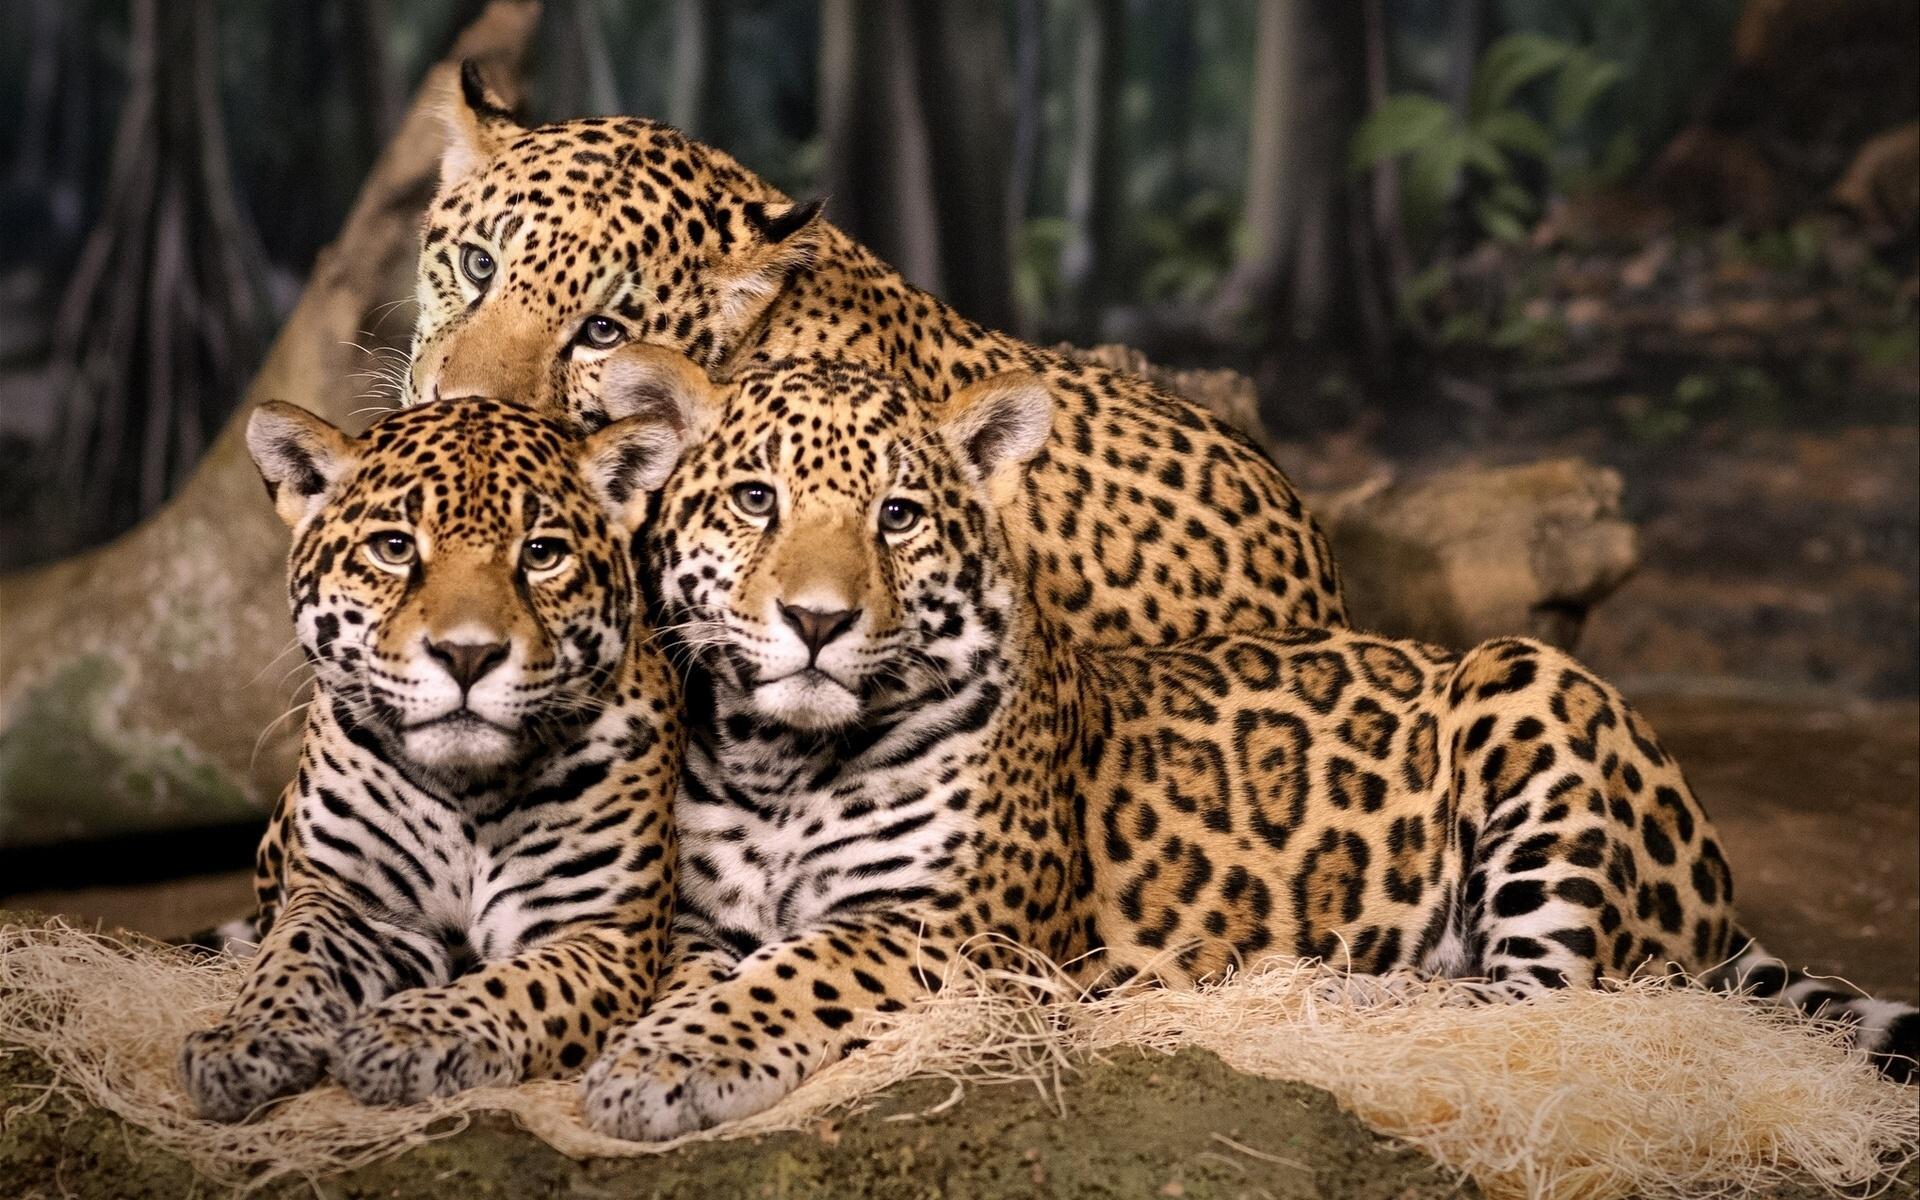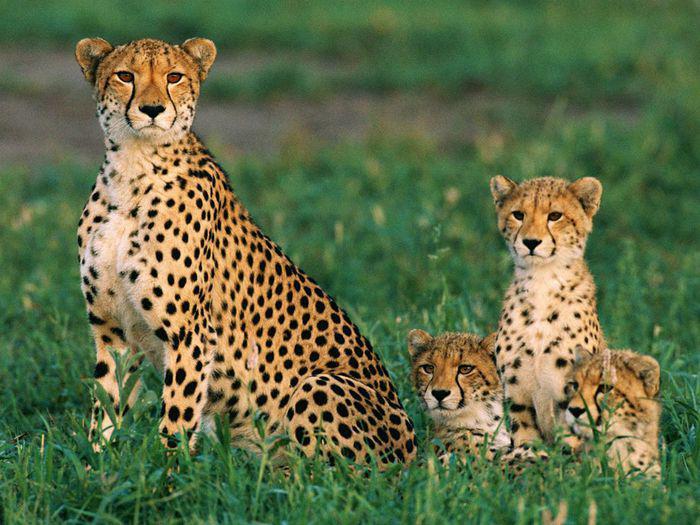The first image is the image on the left, the second image is the image on the right. Given the left and right images, does the statement "One image features baby cheetahs next to an adult cheetah" hold true? Answer yes or no. Yes. The first image is the image on the left, the second image is the image on the right. Given the left and right images, does the statement "The image on the right has one lone cheetah sitting in the grass." hold true? Answer yes or no. No. 